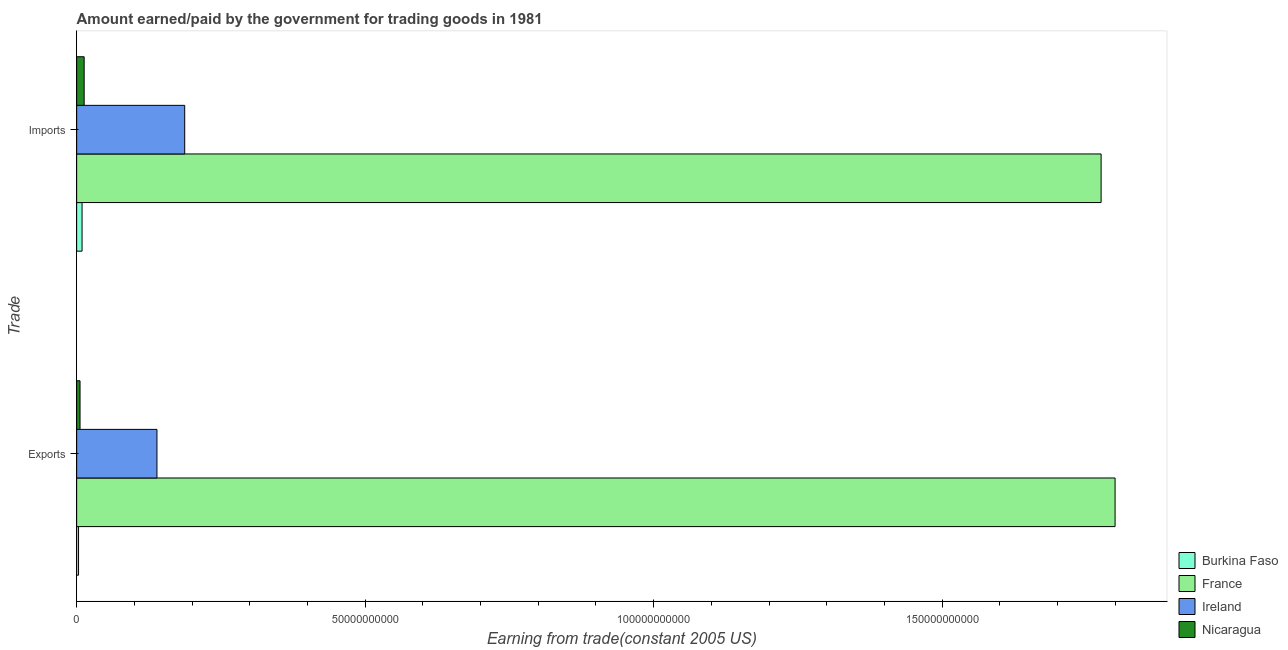How many different coloured bars are there?
Provide a short and direct response. 4. How many groups of bars are there?
Make the answer very short. 2. Are the number of bars on each tick of the Y-axis equal?
Offer a very short reply. Yes. How many bars are there on the 2nd tick from the top?
Your answer should be very brief. 4. How many bars are there on the 1st tick from the bottom?
Offer a terse response. 4. What is the label of the 2nd group of bars from the top?
Your response must be concise. Exports. What is the amount paid for imports in Ireland?
Your answer should be very brief. 1.87e+1. Across all countries, what is the maximum amount paid for imports?
Provide a succinct answer. 1.78e+11. Across all countries, what is the minimum amount earned from exports?
Offer a very short reply. 3.28e+08. In which country was the amount paid for imports maximum?
Make the answer very short. France. In which country was the amount earned from exports minimum?
Give a very brief answer. Burkina Faso. What is the total amount earned from exports in the graph?
Your response must be concise. 1.95e+11. What is the difference between the amount earned from exports in Burkina Faso and that in Nicaragua?
Your response must be concise. -2.57e+08. What is the difference between the amount paid for imports in Nicaragua and the amount earned from exports in France?
Make the answer very short. -1.79e+11. What is the average amount earned from exports per country?
Your response must be concise. 4.87e+1. What is the difference between the amount earned from exports and amount paid for imports in France?
Offer a very short reply. 2.42e+09. What is the ratio of the amount paid for imports in Ireland to that in Nicaragua?
Give a very brief answer. 14.4. In how many countries, is the amount paid for imports greater than the average amount paid for imports taken over all countries?
Your answer should be very brief. 1. What does the 2nd bar from the top in Exports represents?
Provide a short and direct response. Ireland. What does the 2nd bar from the bottom in Exports represents?
Your response must be concise. France. Are all the bars in the graph horizontal?
Provide a succinct answer. Yes. What is the difference between two consecutive major ticks on the X-axis?
Keep it short and to the point. 5.00e+1. How many legend labels are there?
Offer a terse response. 4. How are the legend labels stacked?
Provide a succinct answer. Vertical. What is the title of the graph?
Provide a short and direct response. Amount earned/paid by the government for trading goods in 1981. Does "Burundi" appear as one of the legend labels in the graph?
Provide a short and direct response. No. What is the label or title of the X-axis?
Ensure brevity in your answer.  Earning from trade(constant 2005 US). What is the label or title of the Y-axis?
Your response must be concise. Trade. What is the Earning from trade(constant 2005 US) in Burkina Faso in Exports?
Your answer should be very brief. 3.28e+08. What is the Earning from trade(constant 2005 US) of France in Exports?
Your answer should be compact. 1.80e+11. What is the Earning from trade(constant 2005 US) of Ireland in Exports?
Give a very brief answer. 1.39e+1. What is the Earning from trade(constant 2005 US) of Nicaragua in Exports?
Your answer should be compact. 5.85e+08. What is the Earning from trade(constant 2005 US) of Burkina Faso in Imports?
Keep it short and to the point. 9.37e+08. What is the Earning from trade(constant 2005 US) of France in Imports?
Provide a succinct answer. 1.78e+11. What is the Earning from trade(constant 2005 US) of Ireland in Imports?
Make the answer very short. 1.87e+1. What is the Earning from trade(constant 2005 US) in Nicaragua in Imports?
Your answer should be compact. 1.30e+09. Across all Trade, what is the maximum Earning from trade(constant 2005 US) of Burkina Faso?
Ensure brevity in your answer.  9.37e+08. Across all Trade, what is the maximum Earning from trade(constant 2005 US) in France?
Keep it short and to the point. 1.80e+11. Across all Trade, what is the maximum Earning from trade(constant 2005 US) in Ireland?
Provide a succinct answer. 1.87e+1. Across all Trade, what is the maximum Earning from trade(constant 2005 US) of Nicaragua?
Your response must be concise. 1.30e+09. Across all Trade, what is the minimum Earning from trade(constant 2005 US) of Burkina Faso?
Your response must be concise. 3.28e+08. Across all Trade, what is the minimum Earning from trade(constant 2005 US) in France?
Provide a succinct answer. 1.78e+11. Across all Trade, what is the minimum Earning from trade(constant 2005 US) in Ireland?
Provide a short and direct response. 1.39e+1. Across all Trade, what is the minimum Earning from trade(constant 2005 US) in Nicaragua?
Offer a very short reply. 5.85e+08. What is the total Earning from trade(constant 2005 US) in Burkina Faso in the graph?
Offer a terse response. 1.27e+09. What is the total Earning from trade(constant 2005 US) of France in the graph?
Ensure brevity in your answer.  3.58e+11. What is the total Earning from trade(constant 2005 US) of Ireland in the graph?
Provide a short and direct response. 3.26e+1. What is the total Earning from trade(constant 2005 US) in Nicaragua in the graph?
Ensure brevity in your answer.  1.89e+09. What is the difference between the Earning from trade(constant 2005 US) in Burkina Faso in Exports and that in Imports?
Provide a succinct answer. -6.10e+08. What is the difference between the Earning from trade(constant 2005 US) in France in Exports and that in Imports?
Ensure brevity in your answer.  2.42e+09. What is the difference between the Earning from trade(constant 2005 US) in Ireland in Exports and that in Imports?
Your answer should be compact. -4.81e+09. What is the difference between the Earning from trade(constant 2005 US) of Nicaragua in Exports and that in Imports?
Make the answer very short. -7.15e+08. What is the difference between the Earning from trade(constant 2005 US) in Burkina Faso in Exports and the Earning from trade(constant 2005 US) in France in Imports?
Give a very brief answer. -1.77e+11. What is the difference between the Earning from trade(constant 2005 US) of Burkina Faso in Exports and the Earning from trade(constant 2005 US) of Ireland in Imports?
Your answer should be compact. -1.84e+1. What is the difference between the Earning from trade(constant 2005 US) of Burkina Faso in Exports and the Earning from trade(constant 2005 US) of Nicaragua in Imports?
Make the answer very short. -9.73e+08. What is the difference between the Earning from trade(constant 2005 US) of France in Exports and the Earning from trade(constant 2005 US) of Ireland in Imports?
Give a very brief answer. 1.61e+11. What is the difference between the Earning from trade(constant 2005 US) of France in Exports and the Earning from trade(constant 2005 US) of Nicaragua in Imports?
Offer a terse response. 1.79e+11. What is the difference between the Earning from trade(constant 2005 US) in Ireland in Exports and the Earning from trade(constant 2005 US) in Nicaragua in Imports?
Provide a short and direct response. 1.26e+1. What is the average Earning from trade(constant 2005 US) of Burkina Faso per Trade?
Provide a succinct answer. 6.33e+08. What is the average Earning from trade(constant 2005 US) in France per Trade?
Provide a short and direct response. 1.79e+11. What is the average Earning from trade(constant 2005 US) of Ireland per Trade?
Give a very brief answer. 1.63e+1. What is the average Earning from trade(constant 2005 US) in Nicaragua per Trade?
Offer a very short reply. 9.43e+08. What is the difference between the Earning from trade(constant 2005 US) in Burkina Faso and Earning from trade(constant 2005 US) in France in Exports?
Provide a succinct answer. -1.80e+11. What is the difference between the Earning from trade(constant 2005 US) of Burkina Faso and Earning from trade(constant 2005 US) of Ireland in Exports?
Your answer should be very brief. -1.36e+1. What is the difference between the Earning from trade(constant 2005 US) in Burkina Faso and Earning from trade(constant 2005 US) in Nicaragua in Exports?
Your answer should be very brief. -2.57e+08. What is the difference between the Earning from trade(constant 2005 US) in France and Earning from trade(constant 2005 US) in Ireland in Exports?
Offer a very short reply. 1.66e+11. What is the difference between the Earning from trade(constant 2005 US) of France and Earning from trade(constant 2005 US) of Nicaragua in Exports?
Give a very brief answer. 1.79e+11. What is the difference between the Earning from trade(constant 2005 US) in Ireland and Earning from trade(constant 2005 US) in Nicaragua in Exports?
Your answer should be very brief. 1.33e+1. What is the difference between the Earning from trade(constant 2005 US) of Burkina Faso and Earning from trade(constant 2005 US) of France in Imports?
Keep it short and to the point. -1.77e+11. What is the difference between the Earning from trade(constant 2005 US) of Burkina Faso and Earning from trade(constant 2005 US) of Ireland in Imports?
Keep it short and to the point. -1.78e+1. What is the difference between the Earning from trade(constant 2005 US) in Burkina Faso and Earning from trade(constant 2005 US) in Nicaragua in Imports?
Make the answer very short. -3.63e+08. What is the difference between the Earning from trade(constant 2005 US) of France and Earning from trade(constant 2005 US) of Ireland in Imports?
Your answer should be very brief. 1.59e+11. What is the difference between the Earning from trade(constant 2005 US) in France and Earning from trade(constant 2005 US) in Nicaragua in Imports?
Provide a succinct answer. 1.76e+11. What is the difference between the Earning from trade(constant 2005 US) of Ireland and Earning from trade(constant 2005 US) of Nicaragua in Imports?
Provide a succinct answer. 1.74e+1. What is the ratio of the Earning from trade(constant 2005 US) in Burkina Faso in Exports to that in Imports?
Make the answer very short. 0.35. What is the ratio of the Earning from trade(constant 2005 US) of France in Exports to that in Imports?
Make the answer very short. 1.01. What is the ratio of the Earning from trade(constant 2005 US) in Ireland in Exports to that in Imports?
Ensure brevity in your answer.  0.74. What is the ratio of the Earning from trade(constant 2005 US) of Nicaragua in Exports to that in Imports?
Provide a short and direct response. 0.45. What is the difference between the highest and the second highest Earning from trade(constant 2005 US) in Burkina Faso?
Offer a very short reply. 6.10e+08. What is the difference between the highest and the second highest Earning from trade(constant 2005 US) in France?
Keep it short and to the point. 2.42e+09. What is the difference between the highest and the second highest Earning from trade(constant 2005 US) of Ireland?
Offer a very short reply. 4.81e+09. What is the difference between the highest and the second highest Earning from trade(constant 2005 US) in Nicaragua?
Keep it short and to the point. 7.15e+08. What is the difference between the highest and the lowest Earning from trade(constant 2005 US) of Burkina Faso?
Keep it short and to the point. 6.10e+08. What is the difference between the highest and the lowest Earning from trade(constant 2005 US) of France?
Provide a short and direct response. 2.42e+09. What is the difference between the highest and the lowest Earning from trade(constant 2005 US) in Ireland?
Your answer should be very brief. 4.81e+09. What is the difference between the highest and the lowest Earning from trade(constant 2005 US) of Nicaragua?
Provide a succinct answer. 7.15e+08. 